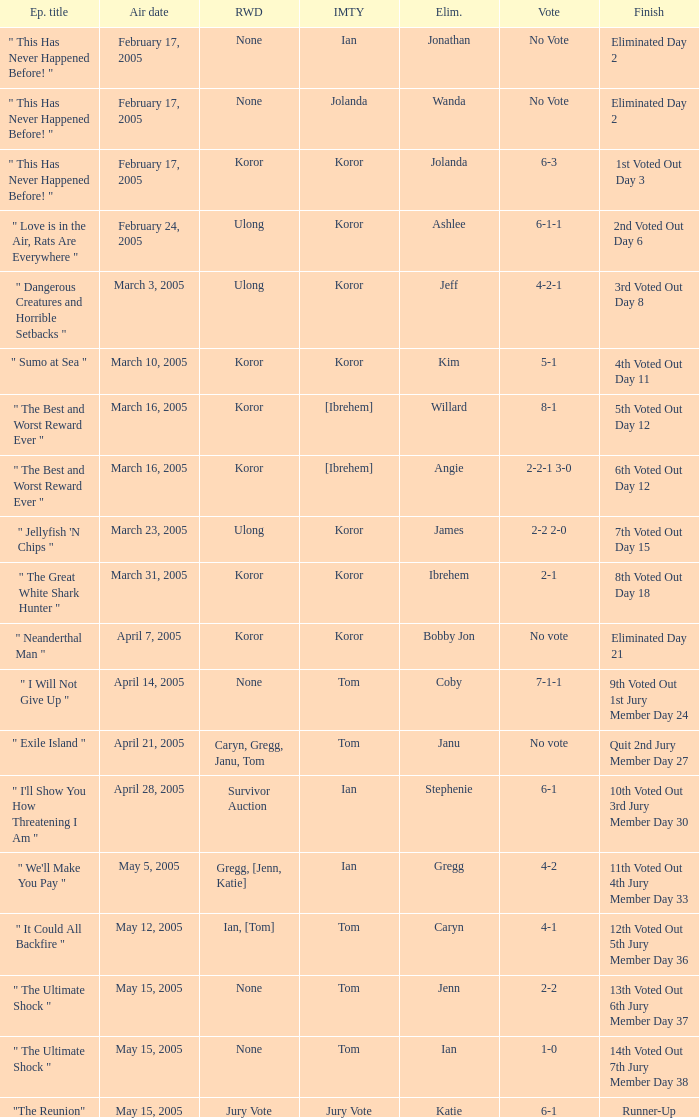How many votes were taken when the outcome was "6th voted out day 12"? 1.0. 